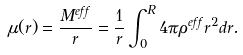Convert formula to latex. <formula><loc_0><loc_0><loc_500><loc_500>\mu ( r ) = \frac { M ^ { e f f } } { r } = \frac { 1 } { r } \int _ { 0 } ^ { R } 4 \pi \rho ^ { e f f } r ^ { 2 } d r .</formula> 